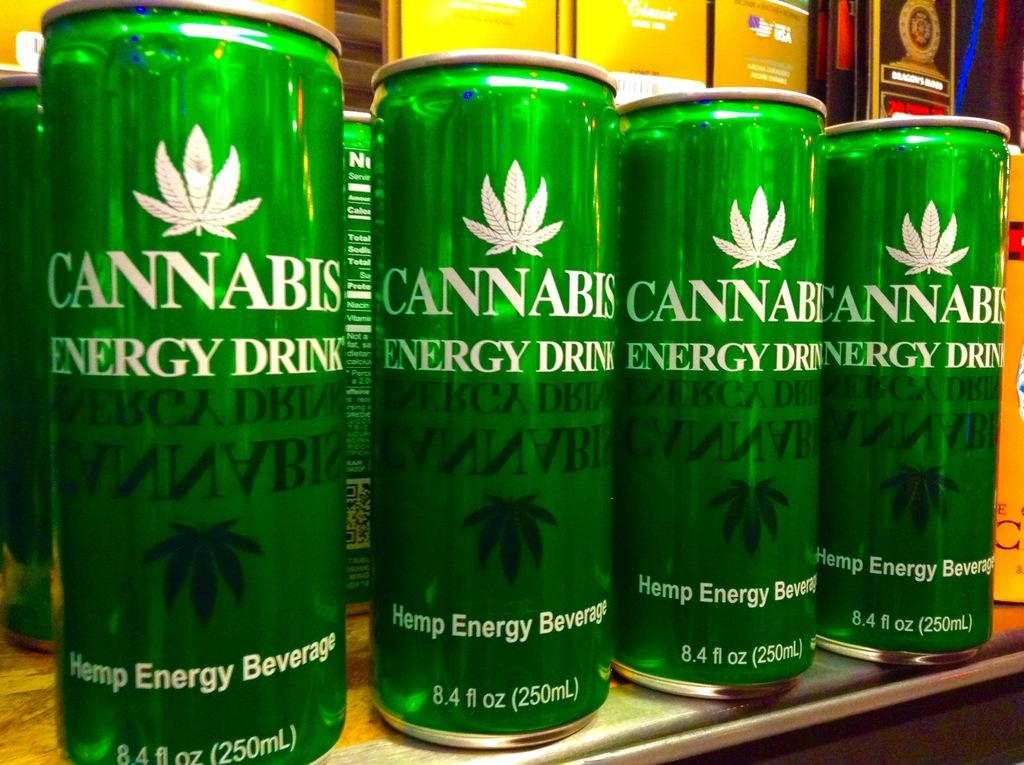<image>
Give a short and clear explanation of the subsequent image. Four 8.4 oz cans that say cannabis Energy Drink 